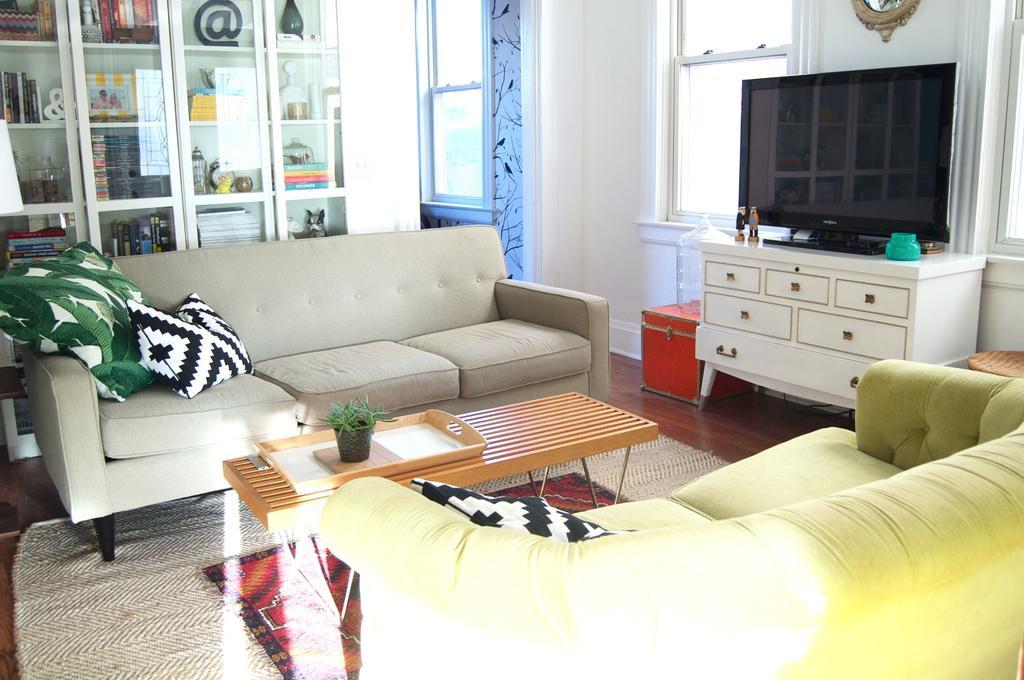How would you summarize this image in a sentence or two? This image is taken inside a room. In the right side of the image there is a sofa with a pillow on it. In the left side of the image there is a floor with mat on it. In the middle of the image there is a table and on top of it there is a tray and in that there is a pot with a plant in it. At the background there is a wall, a showcase, door, windows and curtains and there is a cupboard and on that there is a television. 